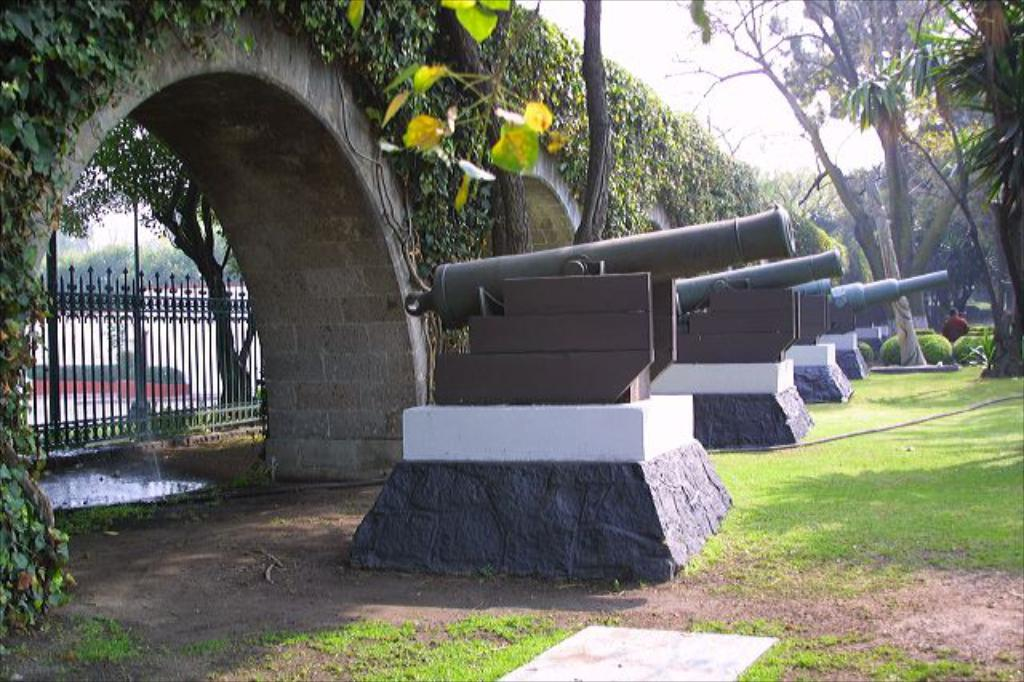What type of military equipment can be seen in the image? There are canons in the image. What type of barrier is present in the image? There is a fence in the image. What type of vegetation is present in the image? There are trees, plants, and grass in the image. What type of liquid is present in the image? There is water in the image. What is visible in the background of the image? The sky is visible in the background of the image. Can you tell me how many beggars are present in the image? There are no beggars present in the image. What type of produce is being grown in the image? There is no produce being grown in the image; it features canons, a fence, trees, plants, grass, water, and the sky. 